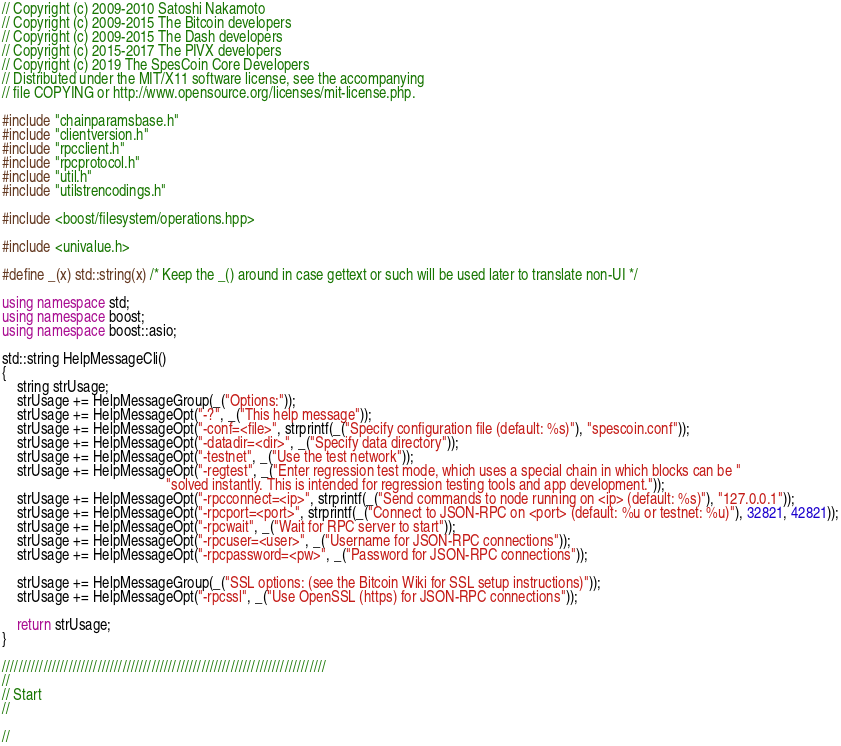<code> <loc_0><loc_0><loc_500><loc_500><_C++_>// Copyright (c) 2009-2010 Satoshi Nakamoto
// Copyright (c) 2009-2015 The Bitcoin developers
// Copyright (c) 2009-2015 The Dash developers
// Copyright (c) 2015-2017 The PIVX developers
// Copyright (c) 2019 The SpesCoin Core Developers
// Distributed under the MIT/X11 software license, see the accompanying
// file COPYING or http://www.opensource.org/licenses/mit-license.php.

#include "chainparamsbase.h"
#include "clientversion.h"
#include "rpcclient.h"
#include "rpcprotocol.h"
#include "util.h"
#include "utilstrencodings.h"

#include <boost/filesystem/operations.hpp>

#include <univalue.h>

#define _(x) std::string(x) /* Keep the _() around in case gettext or such will be used later to translate non-UI */

using namespace std;
using namespace boost;
using namespace boost::asio;

std::string HelpMessageCli()
{
    string strUsage;
    strUsage += HelpMessageGroup(_("Options:"));
    strUsage += HelpMessageOpt("-?", _("This help message"));
    strUsage += HelpMessageOpt("-conf=<file>", strprintf(_("Specify configuration file (default: %s)"), "spescoin.conf"));
    strUsage += HelpMessageOpt("-datadir=<dir>", _("Specify data directory"));
    strUsage += HelpMessageOpt("-testnet", _("Use the test network"));
    strUsage += HelpMessageOpt("-regtest", _("Enter regression test mode, which uses a special chain in which blocks can be "
                                             "solved instantly. This is intended for regression testing tools and app development."));
    strUsage += HelpMessageOpt("-rpcconnect=<ip>", strprintf(_("Send commands to node running on <ip> (default: %s)"), "127.0.0.1"));
    strUsage += HelpMessageOpt("-rpcport=<port>", strprintf(_("Connect to JSON-RPC on <port> (default: %u or testnet: %u)"), 32821, 42821));
    strUsage += HelpMessageOpt("-rpcwait", _("Wait for RPC server to start"));
    strUsage += HelpMessageOpt("-rpcuser=<user>", _("Username for JSON-RPC connections"));
    strUsage += HelpMessageOpt("-rpcpassword=<pw>", _("Password for JSON-RPC connections"));

    strUsage += HelpMessageGroup(_("SSL options: (see the Bitcoin Wiki for SSL setup instructions)"));
    strUsage += HelpMessageOpt("-rpcssl", _("Use OpenSSL (https) for JSON-RPC connections"));

    return strUsage;
}

//////////////////////////////////////////////////////////////////////////////
//
// Start
//

//</code> 